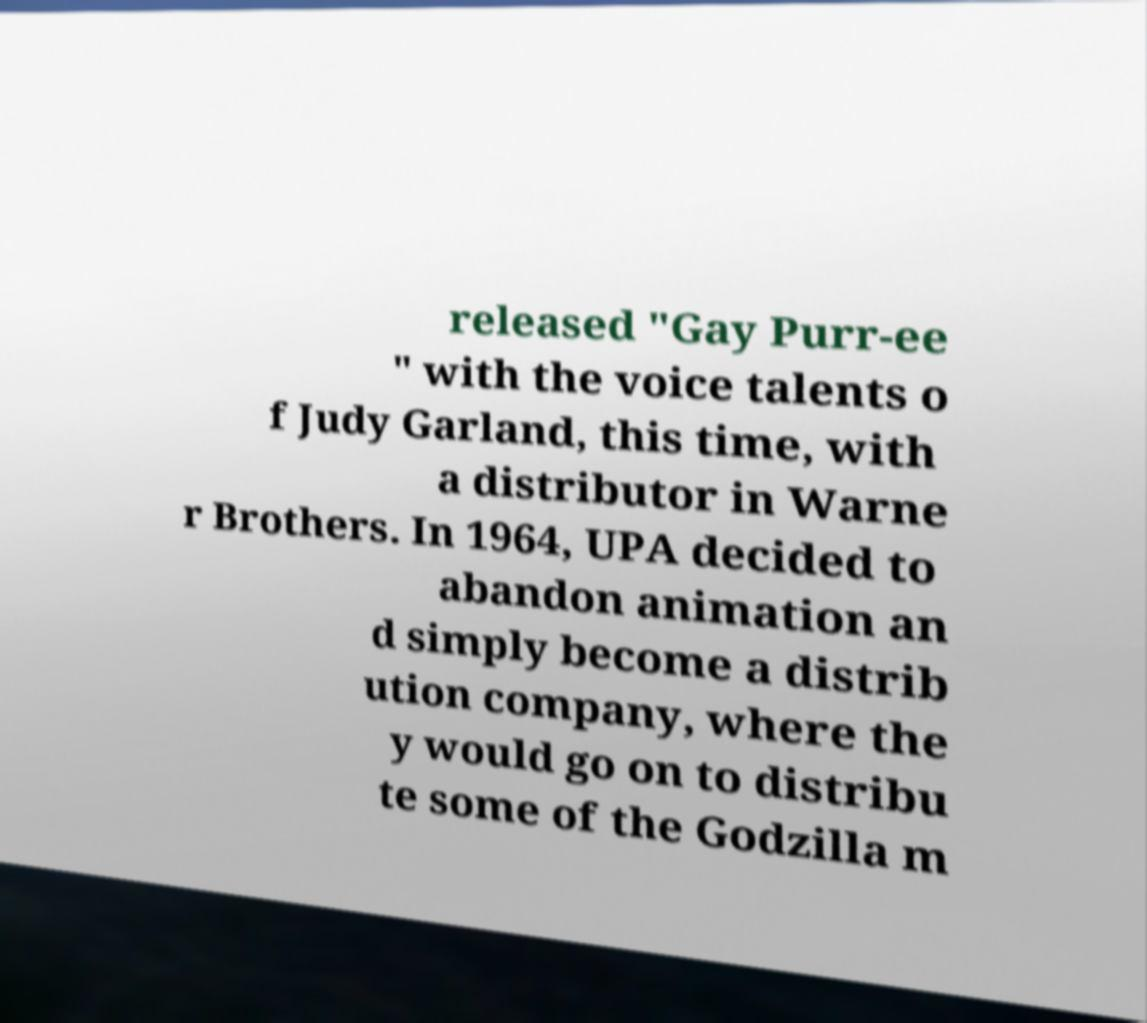Please identify and transcribe the text found in this image. released "Gay Purr-ee " with the voice talents o f Judy Garland, this time, with a distributor in Warne r Brothers. In 1964, UPA decided to abandon animation an d simply become a distrib ution company, where the y would go on to distribu te some of the Godzilla m 